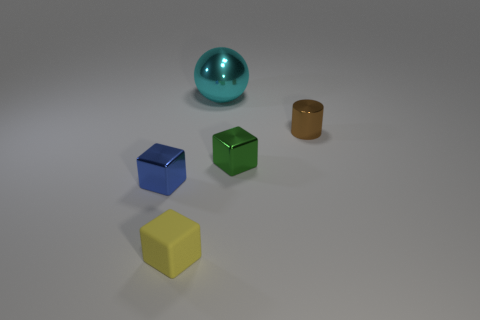Subtract all purple blocks. Subtract all yellow cylinders. How many blocks are left? 3 Subtract all purple balls. How many cyan cylinders are left? 0 Add 5 big cyans. How many tiny greens exist? 0 Subtract all small blue cubes. Subtract all rubber objects. How many objects are left? 3 Add 1 tiny shiny things. How many tiny shiny things are left? 4 Add 1 yellow blocks. How many yellow blocks exist? 2 Add 3 cylinders. How many objects exist? 8 Subtract all yellow blocks. How many blocks are left? 2 Subtract all tiny blue metal blocks. How many blocks are left? 2 Subtract 0 purple balls. How many objects are left? 5 